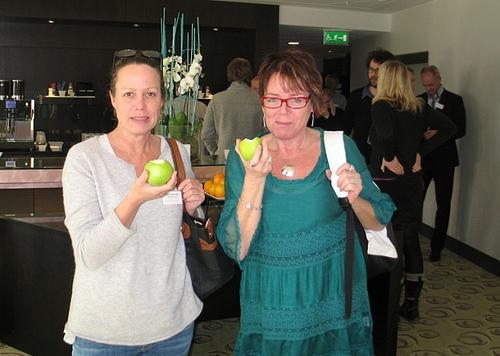How many people are in the image and what common activity are they involved in? There are multiple people in the image, with two women eating apples as the primary focus. Give a brief context to the image, in terms of the location and event. A group of people are standing in a hall or entrance, possibly during a gathering or event. Describe the emotions present in the image, if any. The emotions are likely casual and relaxed as people appear to be socializing and enjoying food. What type of fruit is present in the image, and how many people are interacting with it? Green apples are present, and two women are interacting with them by eating them. Identify the main activity happening in the image. Two women are eating green apples together. What type of objects are the individuals in the center of the image holding? They are holding green apples with some bites taken. Identify any prominent colors that stand out in the image. Green (apples and dress), red (glasses frames), turquoise (dress), black (boots and suits), and white (flowers). Enumerate the types of accessories and clothing items worn by people in the image. Spectacles, necklace, wrist band, black boots, gray socks, turquoise dress, black suit, and red framed glasses. Analyze and point out any anomalies or peculiarities in the image if present. The green sign on the ceiling appears to be out of place, and the tall floral arrangement on the counter is unusually large. What is the man wearing in the gray sweater doing? Unable to determine activity from the given data Is the woman in the black suit wearing a red wrist band? There is a "woman in black suit" (X:362 Y:55 Width:65 Height:65) in the image, but the only wrist band mentioned is a "wrist band" (X:247 Y:203 Width:12 Height:12) with no mention of its color or specifically belonging to the woman in a black suit. What type of fruit is the woman holding in her hand? Apple What action are the women performing with the apples? Eating apples Can you identify any accessories the women are wearing, and provide a brief description? Red glasses, Necklace, Wrist band, Black boots with gray socks, Brown purse, Bracelet, Dangle earrings Can you see the blue flowers on the floor near the entrance? There is a "tall floral arrangement on counter" (X:147 Y:8 Width:57 Height:57) in the image, but it is white, not blue, and it is on the counter, not on the floor. There is also no mention of it being placed near the entrance. Which type of fruit can be found in the bowl? Oranges Describe the type of footwear worn by the woman wearing black boots. Black boots with gray socks Are the two women with apples wearing hats? No, it's not mentioned in the image. Explain the primary event going on in this image. Two women eating apples Describe the appearance of the apple in the image. It is green in color and has a bite missing. Determine whether the man with the beard and mustache is wearing any type of glasses? No glasses mentioned in the data Is there a pink coffee maker on the counter? There is a "coffee maker on counter" (X:1 Y:68 Width:50 Height:50) in the image, but its color is not mentioned, so assuming it is pink would be misleading. How many women are eating apples in the image? Two Can you find the purple apples that the ladies are eating? Although there are "two women eating apples" (X:74 Y:37 Width:321 Height:321), the apples mentioned in the image are "green apples" (X:154 Y:167 Width:11 Height:11) and (X:131 Y:150 Width:45 Height:45), not purple. What is the color of the sign on the ceiling? Green Describe the position of the lady with glasses on her head. Woman is wearing the glasses on her head How many people are standing near the entrance? A group of people Does the man with a beard and mustache have glasses on his head? There is a "man with beard and mustache" (X:353 Y:43 Width:30 Height:30) in the image, but the mentioned glasses are on the "womans head" (X:115 Y:40 Width:51 Height:51) and a "woman with glasses on her head" (X:91 Y:41 Width:85 Height:85), not on the man with a beard and mustache. Describe the expression of the lady with light skin. Unable to determine facial expression from the given data Identify the type of flower arrangement found on the counter. Tall floral arrangement with white flowers and blue sticks Can you discern the color and type of the dress worn by the woman with the apple in her hand? Turquoise dress Mention the color of the coffee maker that can be seen in the image. No specific color is mentioned in the data, but it is on the counter. Choose the correct description of the necklace: (a) Shinny, (b) Dull, (c) Long, (d) Invisible (a) Shinny Are there any objects on the image's wall? Yes, there is a green wall sign. Please list all the people in the picture along with a description of what they are wearing. 1. Woman eating an apple, white outfit. 